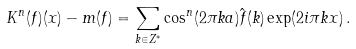<formula> <loc_0><loc_0><loc_500><loc_500>K ^ { n } ( f ) ( x ) - m ( f ) = \sum _ { k \in { Z } ^ { * } } \cos ^ { n } ( 2 \pi k a ) \hat { f } ( k ) \exp ( 2 i \pi k x ) \, .</formula> 